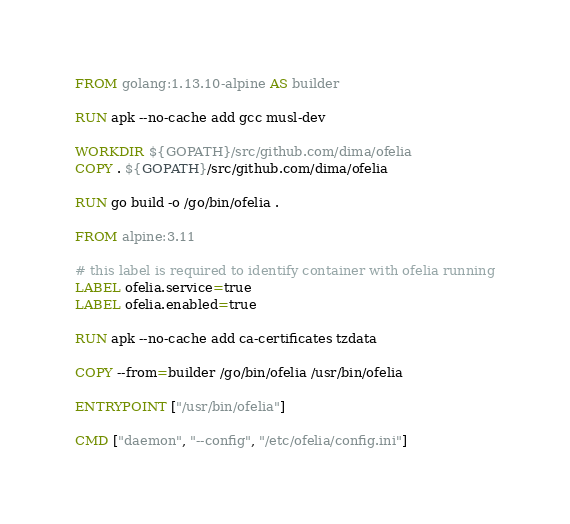Convert code to text. <code><loc_0><loc_0><loc_500><loc_500><_Dockerfile_>FROM golang:1.13.10-alpine AS builder

RUN apk --no-cache add gcc musl-dev

WORKDIR ${GOPATH}/src/github.com/dima/ofelia
COPY . ${GOPATH}/src/github.com/dima/ofelia

RUN go build -o /go/bin/ofelia .

FROM alpine:3.11

# this label is required to identify container with ofelia running
LABEL ofelia.service=true
LABEL ofelia.enabled=true

RUN apk --no-cache add ca-certificates tzdata

COPY --from=builder /go/bin/ofelia /usr/bin/ofelia

ENTRYPOINT ["/usr/bin/ofelia"]

CMD ["daemon", "--config", "/etc/ofelia/config.ini"]
</code> 